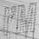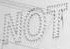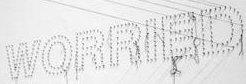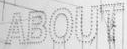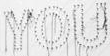Read the text from these images in sequence, separated by a semicolon. I'M; NOT; WORRIED; ABOUT; YOU 